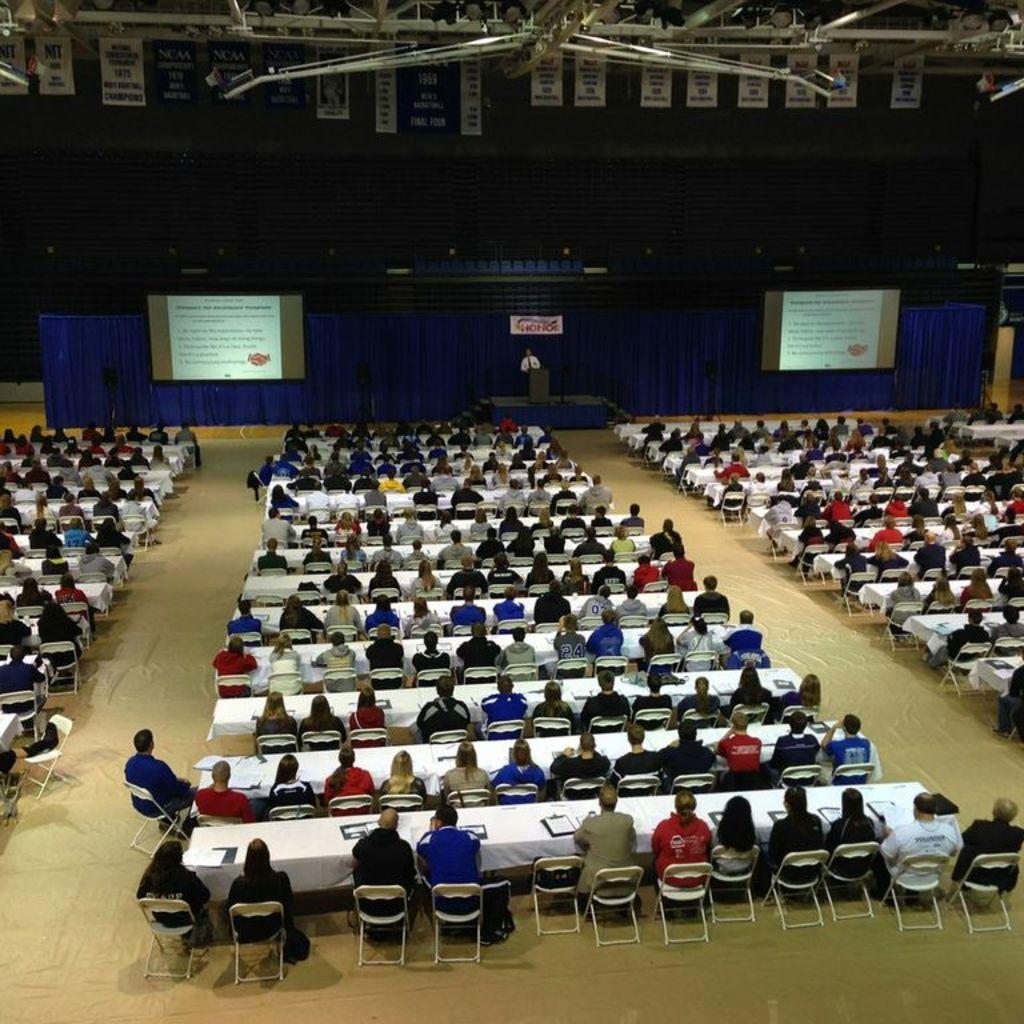How would you summarize this image in a sentence or two? In this image we can see many people sitting on the chairs which are on the floor and they are sitting in front of the tables which are covered with the clothes. In the background we can see the curtain, display screens, banner and also a person standing in front of the podium which is on the stage. At the top we can see the banners and also some rods. 